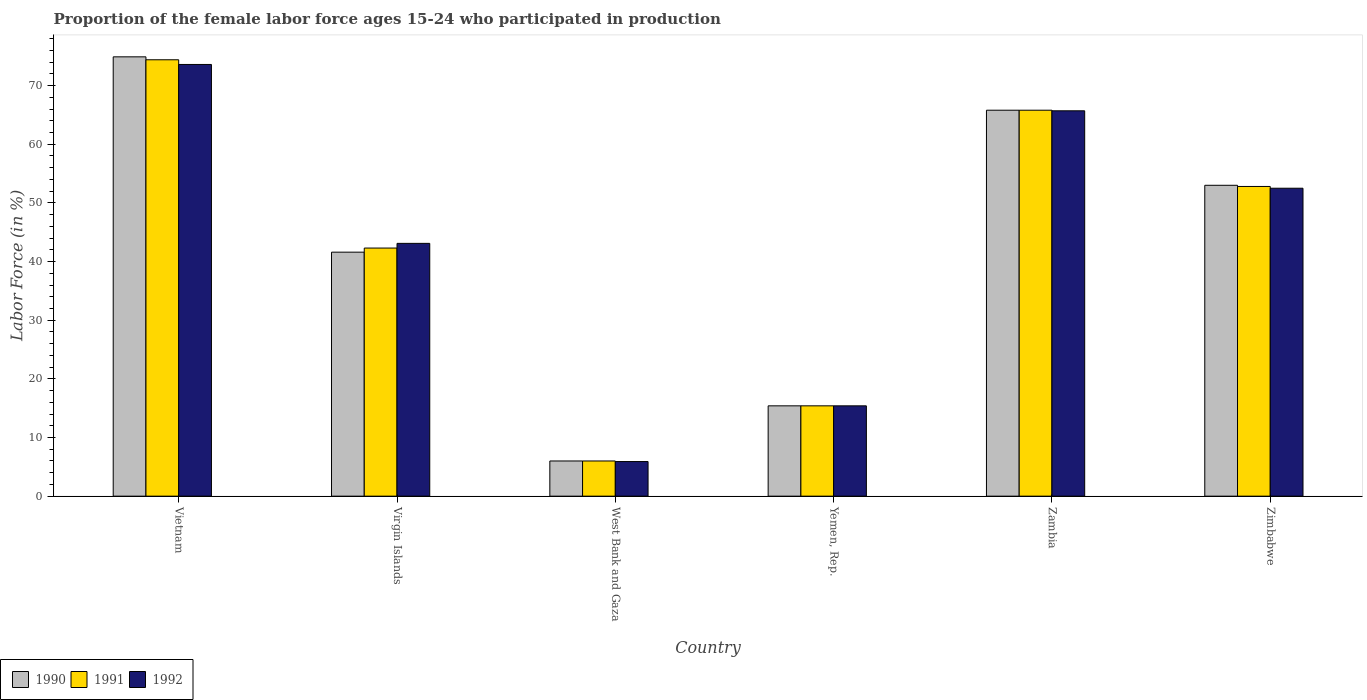How many different coloured bars are there?
Provide a succinct answer. 3. Are the number of bars on each tick of the X-axis equal?
Ensure brevity in your answer.  Yes. How many bars are there on the 3rd tick from the left?
Your answer should be very brief. 3. How many bars are there on the 3rd tick from the right?
Offer a terse response. 3. What is the label of the 2nd group of bars from the left?
Your answer should be compact. Virgin Islands. What is the proportion of the female labor force who participated in production in 1992 in Virgin Islands?
Offer a terse response. 43.1. Across all countries, what is the maximum proportion of the female labor force who participated in production in 1990?
Make the answer very short. 74.9. In which country was the proportion of the female labor force who participated in production in 1990 maximum?
Give a very brief answer. Vietnam. In which country was the proportion of the female labor force who participated in production in 1990 minimum?
Keep it short and to the point. West Bank and Gaza. What is the total proportion of the female labor force who participated in production in 1990 in the graph?
Provide a succinct answer. 256.7. What is the difference between the proportion of the female labor force who participated in production in 1991 in Vietnam and that in Yemen, Rep.?
Your response must be concise. 59. What is the difference between the proportion of the female labor force who participated in production in 1990 in Zimbabwe and the proportion of the female labor force who participated in production in 1991 in Vietnam?
Provide a short and direct response. -21.4. What is the average proportion of the female labor force who participated in production in 1991 per country?
Provide a succinct answer. 42.78. What is the difference between the proportion of the female labor force who participated in production of/in 1991 and proportion of the female labor force who participated in production of/in 1992 in Zambia?
Your answer should be very brief. 0.1. In how many countries, is the proportion of the female labor force who participated in production in 1990 greater than 62 %?
Your answer should be very brief. 2. What is the ratio of the proportion of the female labor force who participated in production in 1990 in Vietnam to that in Yemen, Rep.?
Ensure brevity in your answer.  4.86. What is the difference between the highest and the second highest proportion of the female labor force who participated in production in 1990?
Keep it short and to the point. -9.1. What is the difference between the highest and the lowest proportion of the female labor force who participated in production in 1991?
Offer a very short reply. 68.4. Is it the case that in every country, the sum of the proportion of the female labor force who participated in production in 1991 and proportion of the female labor force who participated in production in 1992 is greater than the proportion of the female labor force who participated in production in 1990?
Your response must be concise. Yes. Are the values on the major ticks of Y-axis written in scientific E-notation?
Offer a very short reply. No. Does the graph contain grids?
Offer a very short reply. No. Where does the legend appear in the graph?
Ensure brevity in your answer.  Bottom left. How are the legend labels stacked?
Your answer should be very brief. Horizontal. What is the title of the graph?
Offer a very short reply. Proportion of the female labor force ages 15-24 who participated in production. Does "1982" appear as one of the legend labels in the graph?
Provide a short and direct response. No. What is the label or title of the X-axis?
Provide a short and direct response. Country. What is the label or title of the Y-axis?
Your answer should be compact. Labor Force (in %). What is the Labor Force (in %) in 1990 in Vietnam?
Make the answer very short. 74.9. What is the Labor Force (in %) of 1991 in Vietnam?
Your response must be concise. 74.4. What is the Labor Force (in %) of 1992 in Vietnam?
Make the answer very short. 73.6. What is the Labor Force (in %) in 1990 in Virgin Islands?
Make the answer very short. 41.6. What is the Labor Force (in %) in 1991 in Virgin Islands?
Offer a terse response. 42.3. What is the Labor Force (in %) in 1992 in Virgin Islands?
Ensure brevity in your answer.  43.1. What is the Labor Force (in %) of 1991 in West Bank and Gaza?
Provide a succinct answer. 6. What is the Labor Force (in %) of 1992 in West Bank and Gaza?
Give a very brief answer. 5.9. What is the Labor Force (in %) of 1990 in Yemen, Rep.?
Give a very brief answer. 15.4. What is the Labor Force (in %) in 1991 in Yemen, Rep.?
Offer a terse response. 15.4. What is the Labor Force (in %) in 1992 in Yemen, Rep.?
Provide a short and direct response. 15.4. What is the Labor Force (in %) in 1990 in Zambia?
Give a very brief answer. 65.8. What is the Labor Force (in %) in 1991 in Zambia?
Make the answer very short. 65.8. What is the Labor Force (in %) of 1992 in Zambia?
Provide a short and direct response. 65.7. What is the Labor Force (in %) in 1991 in Zimbabwe?
Provide a short and direct response. 52.8. What is the Labor Force (in %) in 1992 in Zimbabwe?
Your response must be concise. 52.5. Across all countries, what is the maximum Labor Force (in %) of 1990?
Your answer should be compact. 74.9. Across all countries, what is the maximum Labor Force (in %) of 1991?
Offer a very short reply. 74.4. Across all countries, what is the maximum Labor Force (in %) in 1992?
Your answer should be very brief. 73.6. Across all countries, what is the minimum Labor Force (in %) of 1992?
Give a very brief answer. 5.9. What is the total Labor Force (in %) in 1990 in the graph?
Make the answer very short. 256.7. What is the total Labor Force (in %) of 1991 in the graph?
Your answer should be very brief. 256.7. What is the total Labor Force (in %) in 1992 in the graph?
Provide a short and direct response. 256.2. What is the difference between the Labor Force (in %) of 1990 in Vietnam and that in Virgin Islands?
Keep it short and to the point. 33.3. What is the difference between the Labor Force (in %) in 1991 in Vietnam and that in Virgin Islands?
Your answer should be very brief. 32.1. What is the difference between the Labor Force (in %) in 1992 in Vietnam and that in Virgin Islands?
Your answer should be very brief. 30.5. What is the difference between the Labor Force (in %) of 1990 in Vietnam and that in West Bank and Gaza?
Provide a short and direct response. 68.9. What is the difference between the Labor Force (in %) in 1991 in Vietnam and that in West Bank and Gaza?
Ensure brevity in your answer.  68.4. What is the difference between the Labor Force (in %) of 1992 in Vietnam and that in West Bank and Gaza?
Offer a very short reply. 67.7. What is the difference between the Labor Force (in %) in 1990 in Vietnam and that in Yemen, Rep.?
Provide a succinct answer. 59.5. What is the difference between the Labor Force (in %) of 1992 in Vietnam and that in Yemen, Rep.?
Provide a succinct answer. 58.2. What is the difference between the Labor Force (in %) of 1991 in Vietnam and that in Zambia?
Provide a short and direct response. 8.6. What is the difference between the Labor Force (in %) in 1992 in Vietnam and that in Zambia?
Your answer should be compact. 7.9. What is the difference between the Labor Force (in %) of 1990 in Vietnam and that in Zimbabwe?
Offer a very short reply. 21.9. What is the difference between the Labor Force (in %) of 1991 in Vietnam and that in Zimbabwe?
Your answer should be compact. 21.6. What is the difference between the Labor Force (in %) of 1992 in Vietnam and that in Zimbabwe?
Provide a succinct answer. 21.1. What is the difference between the Labor Force (in %) in 1990 in Virgin Islands and that in West Bank and Gaza?
Your answer should be very brief. 35.6. What is the difference between the Labor Force (in %) in 1991 in Virgin Islands and that in West Bank and Gaza?
Keep it short and to the point. 36.3. What is the difference between the Labor Force (in %) of 1992 in Virgin Islands and that in West Bank and Gaza?
Offer a very short reply. 37.2. What is the difference between the Labor Force (in %) of 1990 in Virgin Islands and that in Yemen, Rep.?
Provide a succinct answer. 26.2. What is the difference between the Labor Force (in %) of 1991 in Virgin Islands and that in Yemen, Rep.?
Ensure brevity in your answer.  26.9. What is the difference between the Labor Force (in %) of 1992 in Virgin Islands and that in Yemen, Rep.?
Offer a terse response. 27.7. What is the difference between the Labor Force (in %) of 1990 in Virgin Islands and that in Zambia?
Ensure brevity in your answer.  -24.2. What is the difference between the Labor Force (in %) of 1991 in Virgin Islands and that in Zambia?
Ensure brevity in your answer.  -23.5. What is the difference between the Labor Force (in %) in 1992 in Virgin Islands and that in Zambia?
Your answer should be compact. -22.6. What is the difference between the Labor Force (in %) of 1990 in Virgin Islands and that in Zimbabwe?
Make the answer very short. -11.4. What is the difference between the Labor Force (in %) in 1991 in Virgin Islands and that in Zimbabwe?
Ensure brevity in your answer.  -10.5. What is the difference between the Labor Force (in %) of 1992 in Virgin Islands and that in Zimbabwe?
Offer a terse response. -9.4. What is the difference between the Labor Force (in %) in 1990 in West Bank and Gaza and that in Yemen, Rep.?
Provide a short and direct response. -9.4. What is the difference between the Labor Force (in %) of 1990 in West Bank and Gaza and that in Zambia?
Keep it short and to the point. -59.8. What is the difference between the Labor Force (in %) in 1991 in West Bank and Gaza and that in Zambia?
Ensure brevity in your answer.  -59.8. What is the difference between the Labor Force (in %) of 1992 in West Bank and Gaza and that in Zambia?
Ensure brevity in your answer.  -59.8. What is the difference between the Labor Force (in %) in 1990 in West Bank and Gaza and that in Zimbabwe?
Make the answer very short. -47. What is the difference between the Labor Force (in %) of 1991 in West Bank and Gaza and that in Zimbabwe?
Offer a terse response. -46.8. What is the difference between the Labor Force (in %) in 1992 in West Bank and Gaza and that in Zimbabwe?
Your response must be concise. -46.6. What is the difference between the Labor Force (in %) in 1990 in Yemen, Rep. and that in Zambia?
Offer a terse response. -50.4. What is the difference between the Labor Force (in %) of 1991 in Yemen, Rep. and that in Zambia?
Offer a terse response. -50.4. What is the difference between the Labor Force (in %) in 1992 in Yemen, Rep. and that in Zambia?
Give a very brief answer. -50.3. What is the difference between the Labor Force (in %) of 1990 in Yemen, Rep. and that in Zimbabwe?
Your response must be concise. -37.6. What is the difference between the Labor Force (in %) of 1991 in Yemen, Rep. and that in Zimbabwe?
Provide a succinct answer. -37.4. What is the difference between the Labor Force (in %) of 1992 in Yemen, Rep. and that in Zimbabwe?
Give a very brief answer. -37.1. What is the difference between the Labor Force (in %) of 1990 in Zambia and that in Zimbabwe?
Make the answer very short. 12.8. What is the difference between the Labor Force (in %) in 1992 in Zambia and that in Zimbabwe?
Offer a terse response. 13.2. What is the difference between the Labor Force (in %) of 1990 in Vietnam and the Labor Force (in %) of 1991 in Virgin Islands?
Offer a very short reply. 32.6. What is the difference between the Labor Force (in %) of 1990 in Vietnam and the Labor Force (in %) of 1992 in Virgin Islands?
Your answer should be compact. 31.8. What is the difference between the Labor Force (in %) of 1991 in Vietnam and the Labor Force (in %) of 1992 in Virgin Islands?
Your response must be concise. 31.3. What is the difference between the Labor Force (in %) in 1990 in Vietnam and the Labor Force (in %) in 1991 in West Bank and Gaza?
Keep it short and to the point. 68.9. What is the difference between the Labor Force (in %) in 1990 in Vietnam and the Labor Force (in %) in 1992 in West Bank and Gaza?
Provide a short and direct response. 69. What is the difference between the Labor Force (in %) of 1991 in Vietnam and the Labor Force (in %) of 1992 in West Bank and Gaza?
Ensure brevity in your answer.  68.5. What is the difference between the Labor Force (in %) in 1990 in Vietnam and the Labor Force (in %) in 1991 in Yemen, Rep.?
Keep it short and to the point. 59.5. What is the difference between the Labor Force (in %) in 1990 in Vietnam and the Labor Force (in %) in 1992 in Yemen, Rep.?
Your answer should be compact. 59.5. What is the difference between the Labor Force (in %) of 1990 in Vietnam and the Labor Force (in %) of 1991 in Zambia?
Provide a succinct answer. 9.1. What is the difference between the Labor Force (in %) in 1990 in Vietnam and the Labor Force (in %) in 1992 in Zambia?
Offer a terse response. 9.2. What is the difference between the Labor Force (in %) in 1990 in Vietnam and the Labor Force (in %) in 1991 in Zimbabwe?
Offer a very short reply. 22.1. What is the difference between the Labor Force (in %) of 1990 in Vietnam and the Labor Force (in %) of 1992 in Zimbabwe?
Your answer should be very brief. 22.4. What is the difference between the Labor Force (in %) of 1991 in Vietnam and the Labor Force (in %) of 1992 in Zimbabwe?
Your answer should be very brief. 21.9. What is the difference between the Labor Force (in %) of 1990 in Virgin Islands and the Labor Force (in %) of 1991 in West Bank and Gaza?
Provide a succinct answer. 35.6. What is the difference between the Labor Force (in %) of 1990 in Virgin Islands and the Labor Force (in %) of 1992 in West Bank and Gaza?
Your response must be concise. 35.7. What is the difference between the Labor Force (in %) in 1991 in Virgin Islands and the Labor Force (in %) in 1992 in West Bank and Gaza?
Your response must be concise. 36.4. What is the difference between the Labor Force (in %) in 1990 in Virgin Islands and the Labor Force (in %) in 1991 in Yemen, Rep.?
Provide a succinct answer. 26.2. What is the difference between the Labor Force (in %) of 1990 in Virgin Islands and the Labor Force (in %) of 1992 in Yemen, Rep.?
Keep it short and to the point. 26.2. What is the difference between the Labor Force (in %) of 1991 in Virgin Islands and the Labor Force (in %) of 1992 in Yemen, Rep.?
Provide a short and direct response. 26.9. What is the difference between the Labor Force (in %) of 1990 in Virgin Islands and the Labor Force (in %) of 1991 in Zambia?
Offer a terse response. -24.2. What is the difference between the Labor Force (in %) in 1990 in Virgin Islands and the Labor Force (in %) in 1992 in Zambia?
Keep it short and to the point. -24.1. What is the difference between the Labor Force (in %) in 1991 in Virgin Islands and the Labor Force (in %) in 1992 in Zambia?
Offer a very short reply. -23.4. What is the difference between the Labor Force (in %) of 1990 in Virgin Islands and the Labor Force (in %) of 1991 in Zimbabwe?
Your answer should be compact. -11.2. What is the difference between the Labor Force (in %) in 1990 in Virgin Islands and the Labor Force (in %) in 1992 in Zimbabwe?
Provide a short and direct response. -10.9. What is the difference between the Labor Force (in %) in 1990 in West Bank and Gaza and the Labor Force (in %) in 1991 in Yemen, Rep.?
Offer a terse response. -9.4. What is the difference between the Labor Force (in %) in 1990 in West Bank and Gaza and the Labor Force (in %) in 1992 in Yemen, Rep.?
Provide a succinct answer. -9.4. What is the difference between the Labor Force (in %) in 1990 in West Bank and Gaza and the Labor Force (in %) in 1991 in Zambia?
Ensure brevity in your answer.  -59.8. What is the difference between the Labor Force (in %) in 1990 in West Bank and Gaza and the Labor Force (in %) in 1992 in Zambia?
Your answer should be compact. -59.7. What is the difference between the Labor Force (in %) in 1991 in West Bank and Gaza and the Labor Force (in %) in 1992 in Zambia?
Provide a short and direct response. -59.7. What is the difference between the Labor Force (in %) of 1990 in West Bank and Gaza and the Labor Force (in %) of 1991 in Zimbabwe?
Give a very brief answer. -46.8. What is the difference between the Labor Force (in %) in 1990 in West Bank and Gaza and the Labor Force (in %) in 1992 in Zimbabwe?
Offer a very short reply. -46.5. What is the difference between the Labor Force (in %) of 1991 in West Bank and Gaza and the Labor Force (in %) of 1992 in Zimbabwe?
Your answer should be compact. -46.5. What is the difference between the Labor Force (in %) of 1990 in Yemen, Rep. and the Labor Force (in %) of 1991 in Zambia?
Keep it short and to the point. -50.4. What is the difference between the Labor Force (in %) in 1990 in Yemen, Rep. and the Labor Force (in %) in 1992 in Zambia?
Make the answer very short. -50.3. What is the difference between the Labor Force (in %) of 1991 in Yemen, Rep. and the Labor Force (in %) of 1992 in Zambia?
Keep it short and to the point. -50.3. What is the difference between the Labor Force (in %) of 1990 in Yemen, Rep. and the Labor Force (in %) of 1991 in Zimbabwe?
Offer a terse response. -37.4. What is the difference between the Labor Force (in %) of 1990 in Yemen, Rep. and the Labor Force (in %) of 1992 in Zimbabwe?
Offer a terse response. -37.1. What is the difference between the Labor Force (in %) of 1991 in Yemen, Rep. and the Labor Force (in %) of 1992 in Zimbabwe?
Offer a terse response. -37.1. What is the difference between the Labor Force (in %) of 1991 in Zambia and the Labor Force (in %) of 1992 in Zimbabwe?
Keep it short and to the point. 13.3. What is the average Labor Force (in %) in 1990 per country?
Provide a succinct answer. 42.78. What is the average Labor Force (in %) of 1991 per country?
Offer a very short reply. 42.78. What is the average Labor Force (in %) in 1992 per country?
Ensure brevity in your answer.  42.7. What is the difference between the Labor Force (in %) in 1990 and Labor Force (in %) in 1991 in Vietnam?
Your response must be concise. 0.5. What is the difference between the Labor Force (in %) of 1990 and Labor Force (in %) of 1991 in Virgin Islands?
Provide a short and direct response. -0.7. What is the difference between the Labor Force (in %) of 1990 and Labor Force (in %) of 1992 in Virgin Islands?
Your answer should be compact. -1.5. What is the difference between the Labor Force (in %) of 1990 and Labor Force (in %) of 1991 in West Bank and Gaza?
Make the answer very short. 0. What is the difference between the Labor Force (in %) in 1990 and Labor Force (in %) in 1992 in West Bank and Gaza?
Keep it short and to the point. 0.1. What is the difference between the Labor Force (in %) of 1991 and Labor Force (in %) of 1992 in West Bank and Gaza?
Make the answer very short. 0.1. What is the difference between the Labor Force (in %) of 1991 and Labor Force (in %) of 1992 in Zambia?
Ensure brevity in your answer.  0.1. What is the difference between the Labor Force (in %) in 1990 and Labor Force (in %) in 1991 in Zimbabwe?
Provide a succinct answer. 0.2. What is the difference between the Labor Force (in %) of 1991 and Labor Force (in %) of 1992 in Zimbabwe?
Ensure brevity in your answer.  0.3. What is the ratio of the Labor Force (in %) of 1990 in Vietnam to that in Virgin Islands?
Offer a very short reply. 1.8. What is the ratio of the Labor Force (in %) in 1991 in Vietnam to that in Virgin Islands?
Provide a short and direct response. 1.76. What is the ratio of the Labor Force (in %) in 1992 in Vietnam to that in Virgin Islands?
Keep it short and to the point. 1.71. What is the ratio of the Labor Force (in %) in 1990 in Vietnam to that in West Bank and Gaza?
Your answer should be very brief. 12.48. What is the ratio of the Labor Force (in %) in 1991 in Vietnam to that in West Bank and Gaza?
Offer a very short reply. 12.4. What is the ratio of the Labor Force (in %) of 1992 in Vietnam to that in West Bank and Gaza?
Provide a short and direct response. 12.47. What is the ratio of the Labor Force (in %) of 1990 in Vietnam to that in Yemen, Rep.?
Offer a very short reply. 4.86. What is the ratio of the Labor Force (in %) of 1991 in Vietnam to that in Yemen, Rep.?
Your answer should be very brief. 4.83. What is the ratio of the Labor Force (in %) in 1992 in Vietnam to that in Yemen, Rep.?
Keep it short and to the point. 4.78. What is the ratio of the Labor Force (in %) of 1990 in Vietnam to that in Zambia?
Ensure brevity in your answer.  1.14. What is the ratio of the Labor Force (in %) of 1991 in Vietnam to that in Zambia?
Give a very brief answer. 1.13. What is the ratio of the Labor Force (in %) of 1992 in Vietnam to that in Zambia?
Give a very brief answer. 1.12. What is the ratio of the Labor Force (in %) in 1990 in Vietnam to that in Zimbabwe?
Your response must be concise. 1.41. What is the ratio of the Labor Force (in %) in 1991 in Vietnam to that in Zimbabwe?
Keep it short and to the point. 1.41. What is the ratio of the Labor Force (in %) in 1992 in Vietnam to that in Zimbabwe?
Offer a terse response. 1.4. What is the ratio of the Labor Force (in %) of 1990 in Virgin Islands to that in West Bank and Gaza?
Provide a short and direct response. 6.93. What is the ratio of the Labor Force (in %) in 1991 in Virgin Islands to that in West Bank and Gaza?
Give a very brief answer. 7.05. What is the ratio of the Labor Force (in %) in 1992 in Virgin Islands to that in West Bank and Gaza?
Provide a succinct answer. 7.31. What is the ratio of the Labor Force (in %) of 1990 in Virgin Islands to that in Yemen, Rep.?
Offer a terse response. 2.7. What is the ratio of the Labor Force (in %) in 1991 in Virgin Islands to that in Yemen, Rep.?
Provide a short and direct response. 2.75. What is the ratio of the Labor Force (in %) of 1992 in Virgin Islands to that in Yemen, Rep.?
Your answer should be compact. 2.8. What is the ratio of the Labor Force (in %) of 1990 in Virgin Islands to that in Zambia?
Your response must be concise. 0.63. What is the ratio of the Labor Force (in %) of 1991 in Virgin Islands to that in Zambia?
Give a very brief answer. 0.64. What is the ratio of the Labor Force (in %) of 1992 in Virgin Islands to that in Zambia?
Ensure brevity in your answer.  0.66. What is the ratio of the Labor Force (in %) of 1990 in Virgin Islands to that in Zimbabwe?
Provide a succinct answer. 0.78. What is the ratio of the Labor Force (in %) in 1991 in Virgin Islands to that in Zimbabwe?
Your answer should be compact. 0.8. What is the ratio of the Labor Force (in %) in 1992 in Virgin Islands to that in Zimbabwe?
Provide a short and direct response. 0.82. What is the ratio of the Labor Force (in %) in 1990 in West Bank and Gaza to that in Yemen, Rep.?
Your answer should be very brief. 0.39. What is the ratio of the Labor Force (in %) of 1991 in West Bank and Gaza to that in Yemen, Rep.?
Your response must be concise. 0.39. What is the ratio of the Labor Force (in %) of 1992 in West Bank and Gaza to that in Yemen, Rep.?
Offer a very short reply. 0.38. What is the ratio of the Labor Force (in %) in 1990 in West Bank and Gaza to that in Zambia?
Offer a very short reply. 0.09. What is the ratio of the Labor Force (in %) in 1991 in West Bank and Gaza to that in Zambia?
Make the answer very short. 0.09. What is the ratio of the Labor Force (in %) of 1992 in West Bank and Gaza to that in Zambia?
Provide a succinct answer. 0.09. What is the ratio of the Labor Force (in %) of 1990 in West Bank and Gaza to that in Zimbabwe?
Offer a very short reply. 0.11. What is the ratio of the Labor Force (in %) in 1991 in West Bank and Gaza to that in Zimbabwe?
Provide a short and direct response. 0.11. What is the ratio of the Labor Force (in %) in 1992 in West Bank and Gaza to that in Zimbabwe?
Ensure brevity in your answer.  0.11. What is the ratio of the Labor Force (in %) in 1990 in Yemen, Rep. to that in Zambia?
Your answer should be very brief. 0.23. What is the ratio of the Labor Force (in %) of 1991 in Yemen, Rep. to that in Zambia?
Your response must be concise. 0.23. What is the ratio of the Labor Force (in %) in 1992 in Yemen, Rep. to that in Zambia?
Your response must be concise. 0.23. What is the ratio of the Labor Force (in %) of 1990 in Yemen, Rep. to that in Zimbabwe?
Make the answer very short. 0.29. What is the ratio of the Labor Force (in %) in 1991 in Yemen, Rep. to that in Zimbabwe?
Your answer should be very brief. 0.29. What is the ratio of the Labor Force (in %) of 1992 in Yemen, Rep. to that in Zimbabwe?
Offer a very short reply. 0.29. What is the ratio of the Labor Force (in %) of 1990 in Zambia to that in Zimbabwe?
Give a very brief answer. 1.24. What is the ratio of the Labor Force (in %) in 1991 in Zambia to that in Zimbabwe?
Your response must be concise. 1.25. What is the ratio of the Labor Force (in %) of 1992 in Zambia to that in Zimbabwe?
Keep it short and to the point. 1.25. What is the difference between the highest and the second highest Labor Force (in %) in 1990?
Ensure brevity in your answer.  9.1. What is the difference between the highest and the second highest Labor Force (in %) in 1991?
Offer a terse response. 8.6. What is the difference between the highest and the lowest Labor Force (in %) of 1990?
Offer a very short reply. 68.9. What is the difference between the highest and the lowest Labor Force (in %) of 1991?
Your response must be concise. 68.4. What is the difference between the highest and the lowest Labor Force (in %) of 1992?
Offer a terse response. 67.7. 